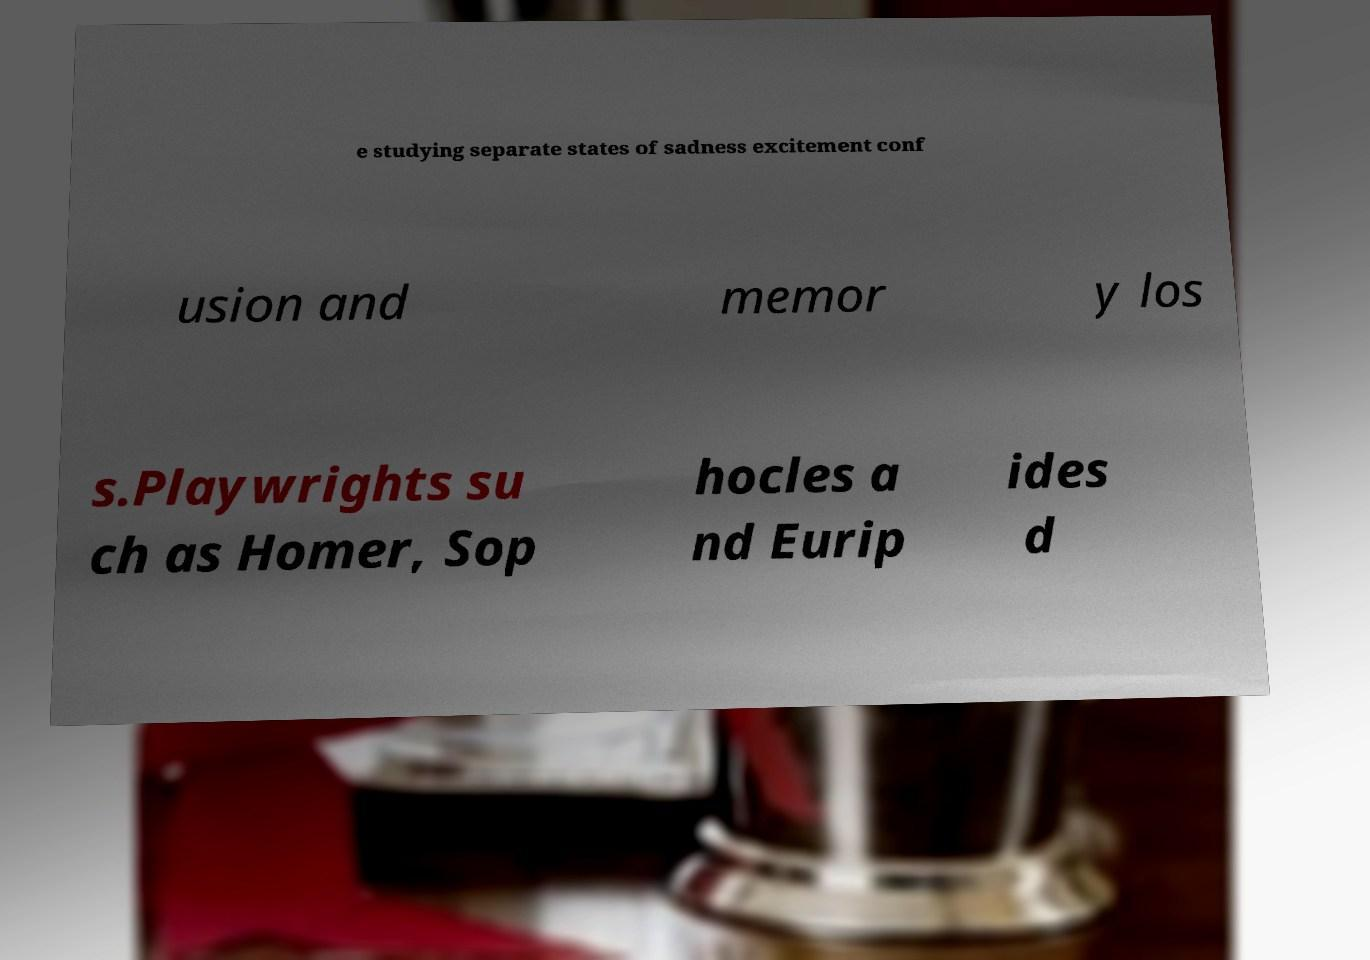Can you read and provide the text displayed in the image?This photo seems to have some interesting text. Can you extract and type it out for me? e studying separate states of sadness excitement conf usion and memor y los s.Playwrights su ch as Homer, Sop hocles a nd Eurip ides d 